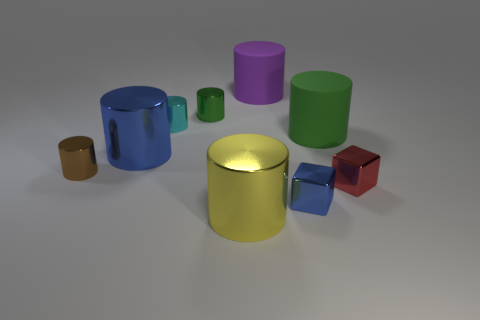Subtract all shiny cylinders. How many cylinders are left? 2 Subtract all brown cylinders. How many cylinders are left? 6 Subtract 2 blocks. How many blocks are left? 0 Subtract all blue cylinders. How many gray cubes are left? 0 Add 1 small shiny objects. How many objects exist? 10 Subtract 0 purple spheres. How many objects are left? 9 Subtract all cubes. How many objects are left? 7 Subtract all cyan blocks. Subtract all cyan cylinders. How many blocks are left? 2 Subtract all blue shiny cylinders. Subtract all yellow metallic things. How many objects are left? 7 Add 6 yellow things. How many yellow things are left? 7 